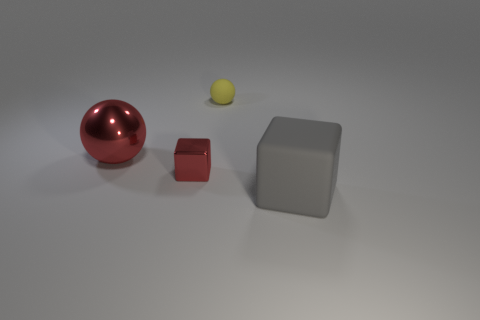Is the number of large brown blocks less than the number of large spheres?
Offer a very short reply. Yes. There is a ball that is the same size as the gray matte cube; what is it made of?
Offer a very short reply. Metal. There is a tiny shiny cube; is it the same color as the sphere in front of the yellow rubber thing?
Your answer should be very brief. Yes. Is the number of balls in front of the gray cube less than the number of tiny red metallic cubes?
Keep it short and to the point. Yes. What number of small matte things are there?
Your response must be concise. 1. There is a thing that is right of the yellow matte ball that is behind the gray block; what shape is it?
Provide a short and direct response. Cube. How many big red objects are right of the big matte cube?
Your answer should be very brief. 0. Does the small red block have the same material as the large thing behind the rubber block?
Provide a short and direct response. Yes. Is there a gray matte thing that has the same size as the metallic sphere?
Make the answer very short. Yes. Are there an equal number of red things in front of the large red shiny sphere and big gray cubes?
Offer a very short reply. Yes. 